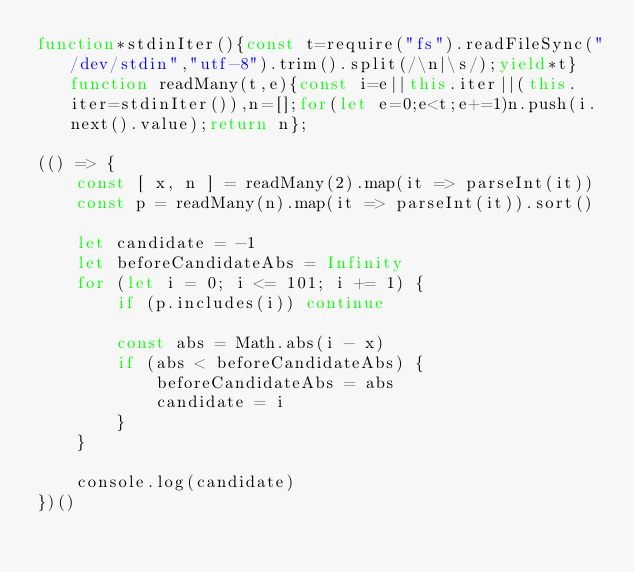<code> <loc_0><loc_0><loc_500><loc_500><_JavaScript_>function*stdinIter(){const t=require("fs").readFileSync("/dev/stdin","utf-8").trim().split(/\n|\s/);yield*t}function readMany(t,e){const i=e||this.iter||(this.iter=stdinIter()),n=[];for(let e=0;e<t;e+=1)n.push(i.next().value);return n};

(() => {
    const [ x, n ] = readMany(2).map(it => parseInt(it))
    const p = readMany(n).map(it => parseInt(it)).sort()

    let candidate = -1
    let beforeCandidateAbs = Infinity
    for (let i = 0; i <= 101; i += 1) {
        if (p.includes(i)) continue

        const abs = Math.abs(i - x)
        if (abs < beforeCandidateAbs) {
            beforeCandidateAbs = abs
            candidate = i
        }
    }

    console.log(candidate)
})()
</code> 